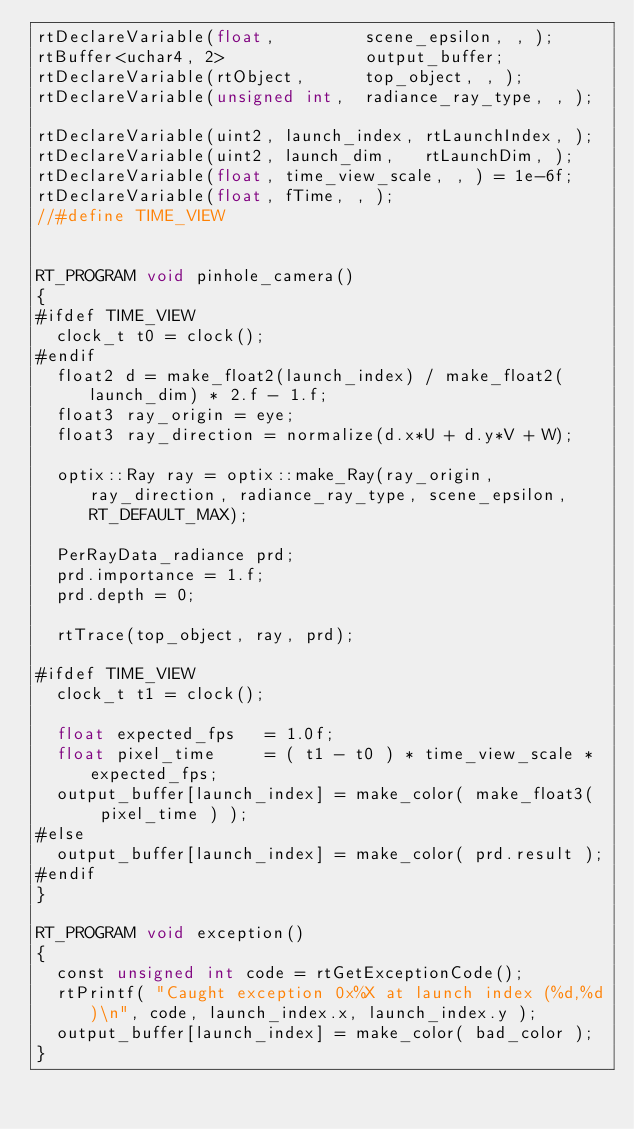Convert code to text. <code><loc_0><loc_0><loc_500><loc_500><_Cuda_>rtDeclareVariable(float,         scene_epsilon, , );
rtBuffer<uchar4, 2>              output_buffer;
rtDeclareVariable(rtObject,      top_object, , );
rtDeclareVariable(unsigned int,  radiance_ray_type, , );

rtDeclareVariable(uint2, launch_index, rtLaunchIndex, );
rtDeclareVariable(uint2, launch_dim,   rtLaunchDim, );
rtDeclareVariable(float, time_view_scale, , ) = 1e-6f;
rtDeclareVariable(float, fTime, , ); 
//#define TIME_VIEW


RT_PROGRAM void pinhole_camera()
{
#ifdef TIME_VIEW
  clock_t t0 = clock(); 
#endif
  float2 d = make_float2(launch_index) / make_float2(launch_dim) * 2.f - 1.f;
  float3 ray_origin = eye;
  float3 ray_direction = normalize(d.x*U + d.y*V + W);
  
  optix::Ray ray = optix::make_Ray(ray_origin, ray_direction, radiance_ray_type, scene_epsilon, RT_DEFAULT_MAX);

  PerRayData_radiance prd;
  prd.importance = 1.f;
  prd.depth = 0;

  rtTrace(top_object, ray, prd);

#ifdef TIME_VIEW
  clock_t t1 = clock(); 
 
  float expected_fps   = 1.0f;
  float pixel_time     = ( t1 - t0 ) * time_view_scale * expected_fps;
  output_buffer[launch_index] = make_color( make_float3(  pixel_time ) ); 
#else
  output_buffer[launch_index] = make_color( prd.result );
#endif
}

RT_PROGRAM void exception()
{
  const unsigned int code = rtGetExceptionCode();
  rtPrintf( "Caught exception 0x%X at launch index (%d,%d)\n", code, launch_index.x, launch_index.y );
  output_buffer[launch_index] = make_color( bad_color );
}
</code> 